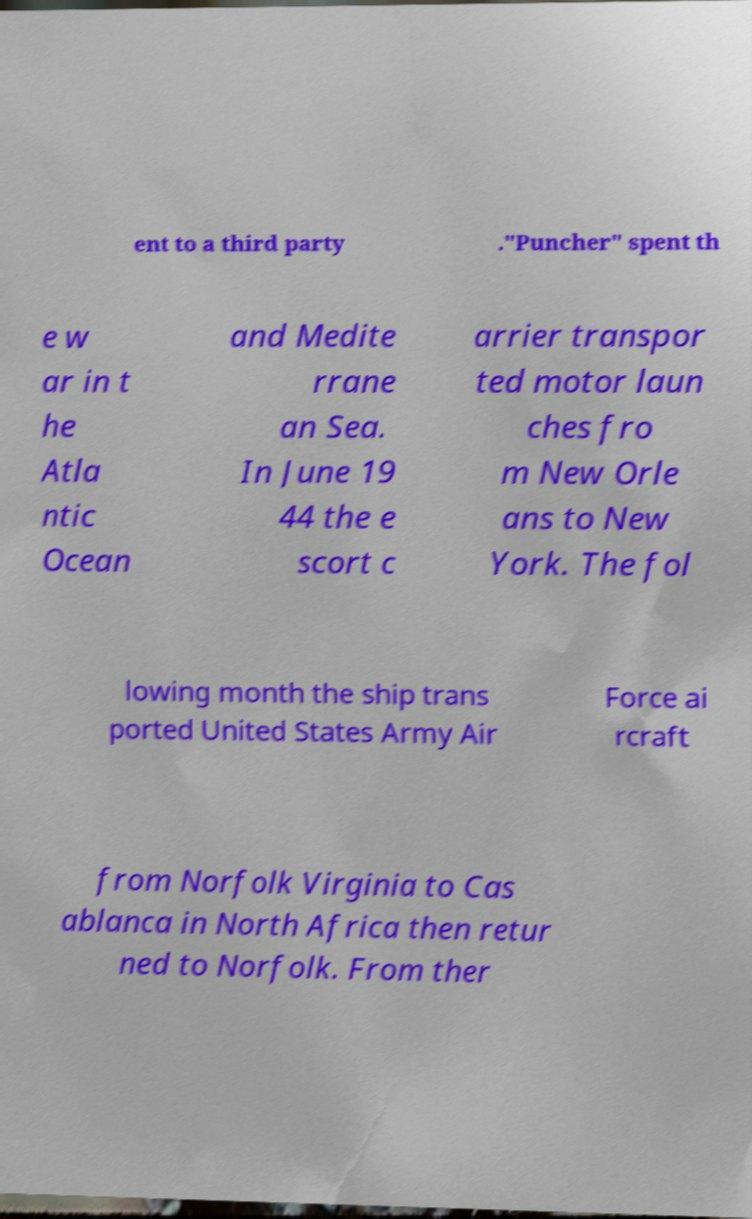I need the written content from this picture converted into text. Can you do that? ent to a third party ."Puncher" spent th e w ar in t he Atla ntic Ocean and Medite rrane an Sea. In June 19 44 the e scort c arrier transpor ted motor laun ches fro m New Orle ans to New York. The fol lowing month the ship trans ported United States Army Air Force ai rcraft from Norfolk Virginia to Cas ablanca in North Africa then retur ned to Norfolk. From ther 